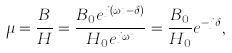<formula> <loc_0><loc_0><loc_500><loc_500>\mu = { \frac { B } { H } } = { \frac { B _ { 0 } e ^ { j \left ( \omega t - \delta \right ) } } { H _ { 0 } e ^ { j \omega t } } } = { \frac { B _ { 0 } } { H _ { 0 } } } e ^ { - j \delta } ,</formula> 